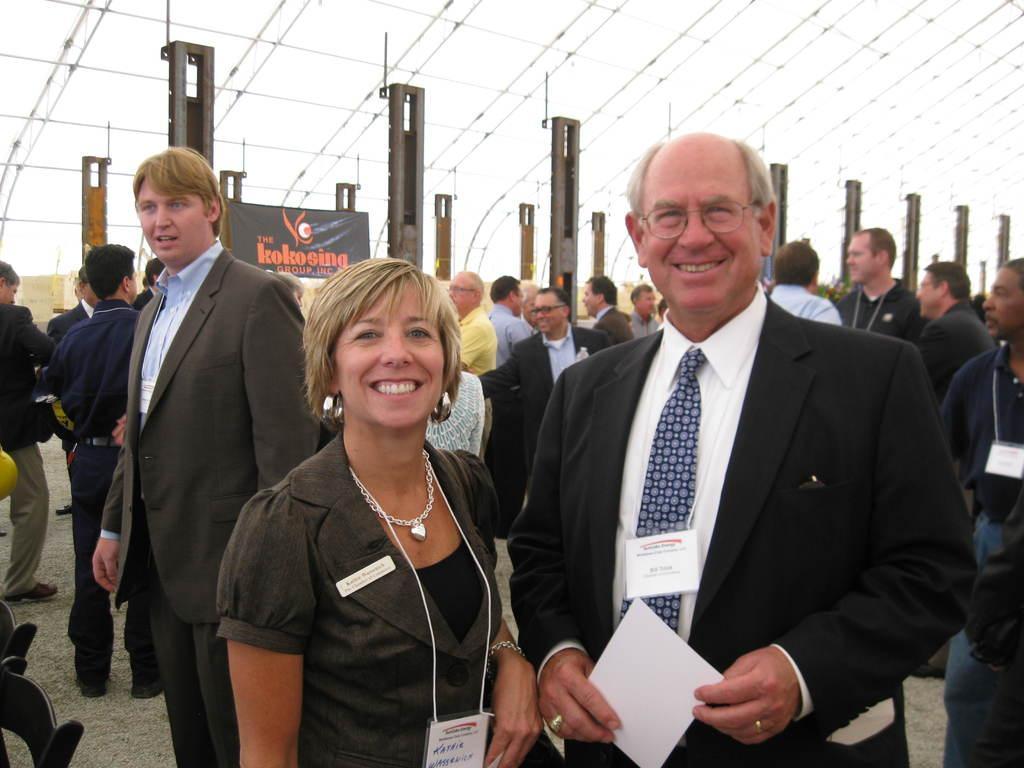Can you describe this image briefly? In this image in front there are two people wearing a smile on their faces. Behind them there are a few other people. In the background of the image there are metal rods. There is a banner. 